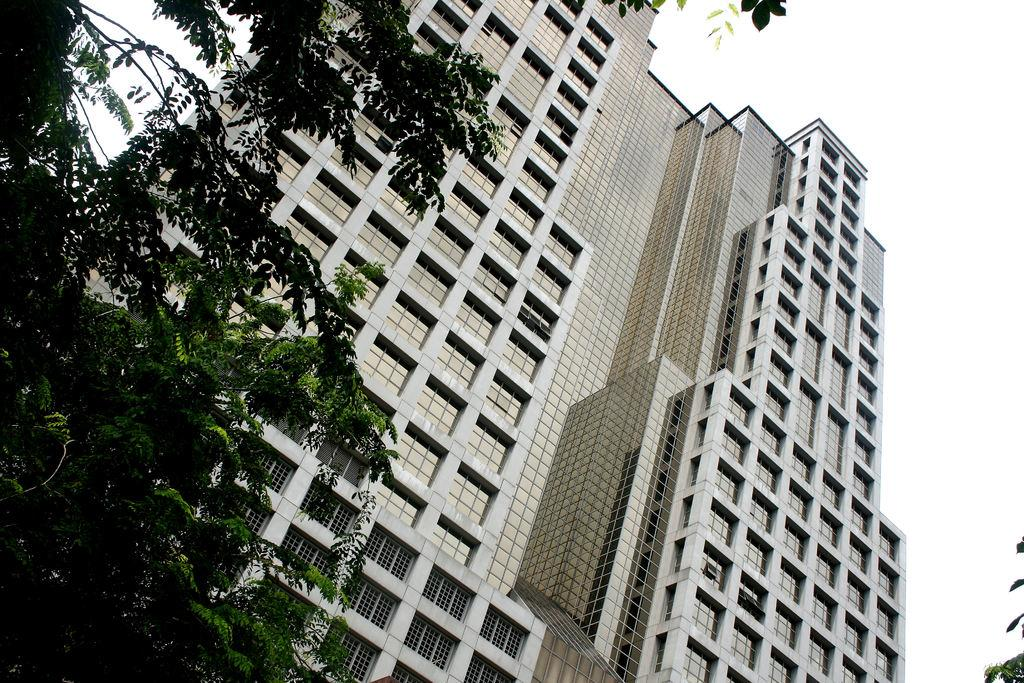What type of vegetation can be seen in the image? There are trees in the image. What type of structure is present in the image? There is a tower building in the image. What is visible in the background of the image? The sky is visible in the background of the image. Can you tell me how many pieces of chalk are on the ground in the image? There is no chalk present in the image. What type of animal is grazing near the tower building in the image? There are no animals present in the image, including yaks. 